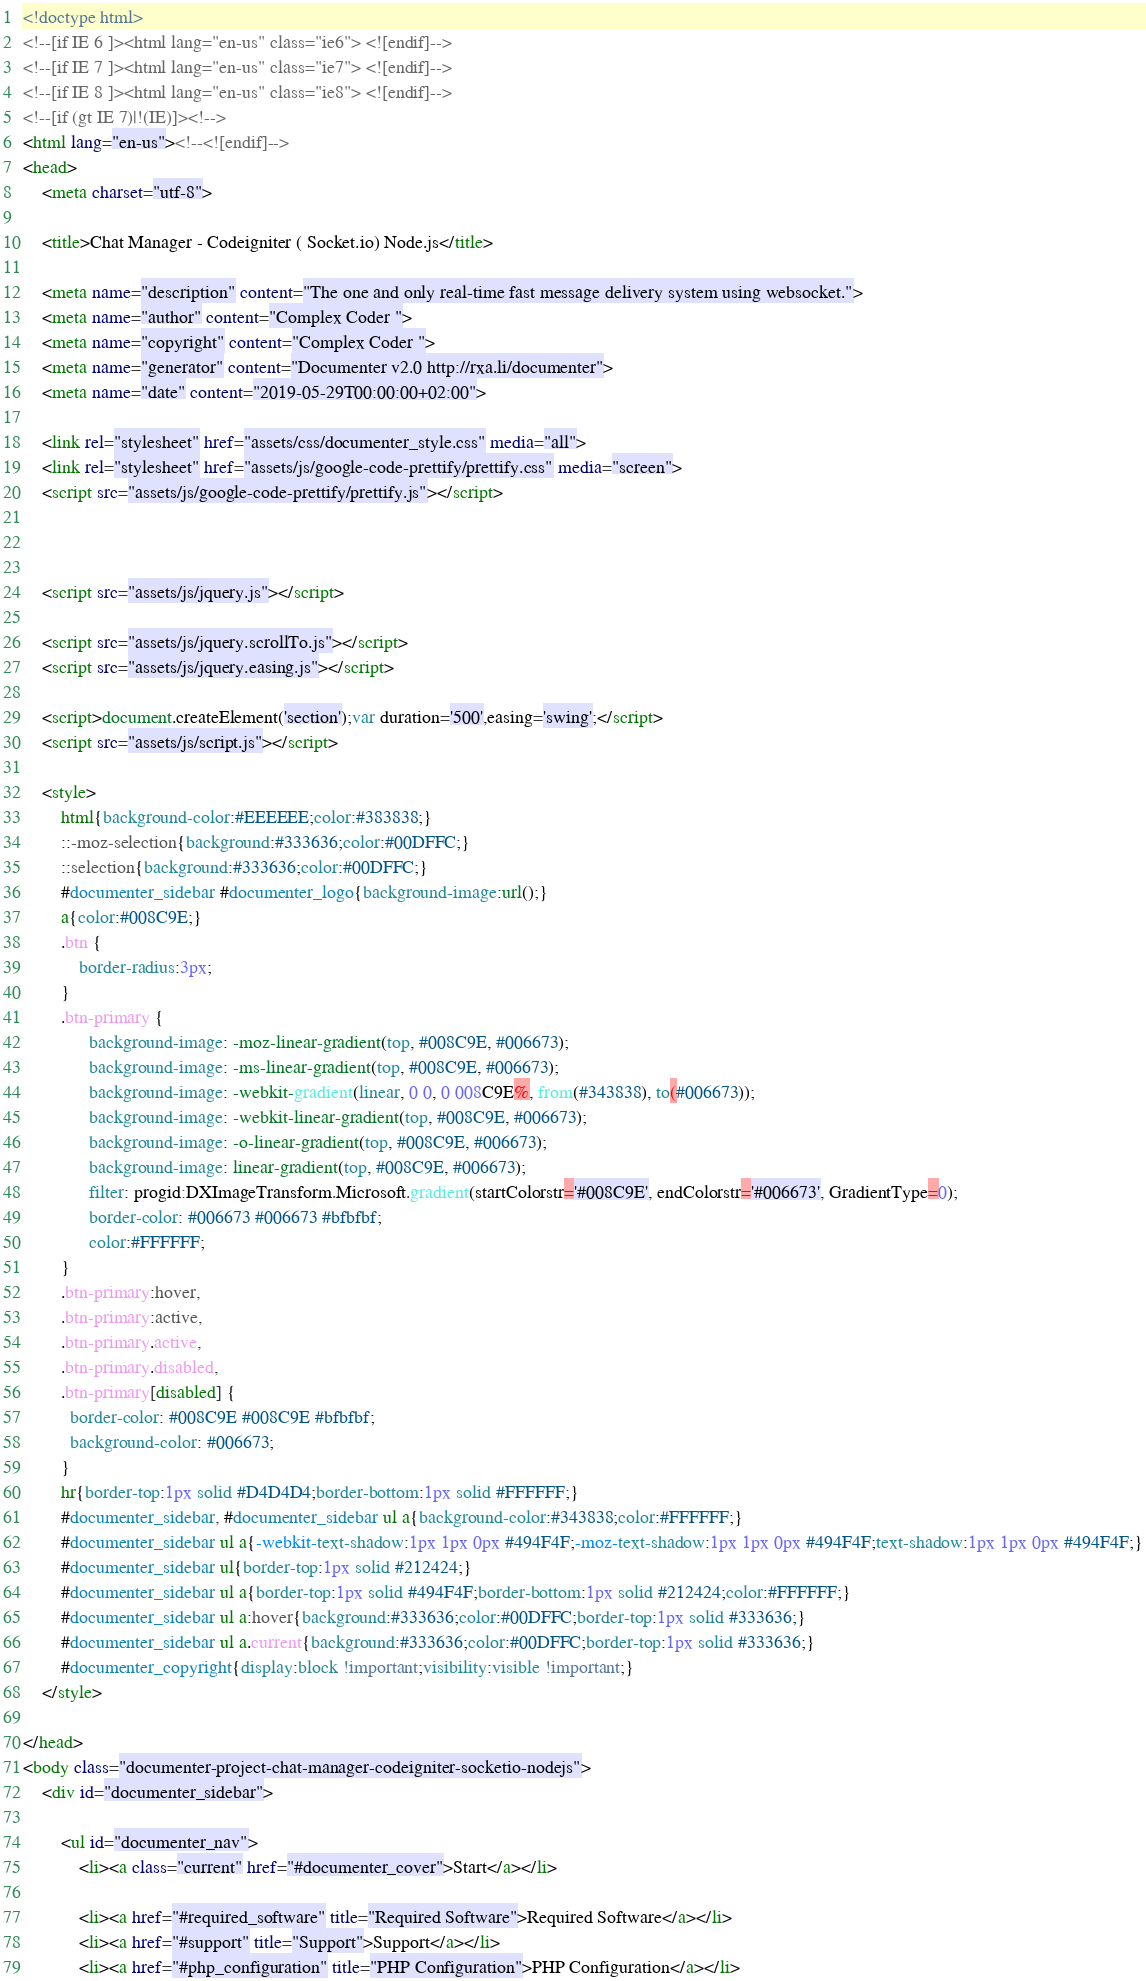Convert code to text. <code><loc_0><loc_0><loc_500><loc_500><_HTML_><!doctype html>  
<!--[if IE 6 ]><html lang="en-us" class="ie6"> <![endif]-->
<!--[if IE 7 ]><html lang="en-us" class="ie7"> <![endif]-->
<!--[if IE 8 ]><html lang="en-us" class="ie8"> <![endif]-->
<!--[if (gt IE 7)|!(IE)]><!-->
<html lang="en-us"><!--<![endif]-->
<head>
	<meta charset="utf-8">
	
	<title>Chat Manager - Codeigniter ( Socket.io) Node.js</title>
	
	<meta name="description" content="The one and only real-time fast message delivery system using websocket.">
	<meta name="author" content="Complex Coder ">
	<meta name="copyright" content="Complex Coder ">
	<meta name="generator" content="Documenter v2.0 http://rxa.li/documenter">
	<meta name="date" content="2019-05-29T00:00:00+02:00">
	
	<link rel="stylesheet" href="assets/css/documenter_style.css" media="all">
	<link rel="stylesheet" href="assets/js/google-code-prettify/prettify.css" media="screen">
	<script src="assets/js/google-code-prettify/prettify.js"></script>

	
	
	<script src="assets/js/jquery.js"></script>
	
	<script src="assets/js/jquery.scrollTo.js"></script>
	<script src="assets/js/jquery.easing.js"></script>
	
	<script>document.createElement('section');var duration='500',easing='swing';</script>
	<script src="assets/js/script.js"></script>
	
	<style>
		html{background-color:#EEEEEE;color:#383838;}
		::-moz-selection{background:#333636;color:#00DFFC;}
		::selection{background:#333636;color:#00DFFC;}
		#documenter_sidebar #documenter_logo{background-image:url();}
		a{color:#008C9E;}
		.btn {
			border-radius:3px;
		}
		.btn-primary {
			  background-image: -moz-linear-gradient(top, #008C9E, #006673);
			  background-image: -ms-linear-gradient(top, #008C9E, #006673);
			  background-image: -webkit-gradient(linear, 0 0, 0 008C9E%, from(#343838), to(#006673));
			  background-image: -webkit-linear-gradient(top, #008C9E, #006673);
			  background-image: -o-linear-gradient(top, #008C9E, #006673);
			  background-image: linear-gradient(top, #008C9E, #006673);
			  filter: progid:DXImageTransform.Microsoft.gradient(startColorstr='#008C9E', endColorstr='#006673', GradientType=0);
			  border-color: #006673 #006673 #bfbfbf;
			  color:#FFFFFF;
		}
		.btn-primary:hover,
		.btn-primary:active,
		.btn-primary.active,
		.btn-primary.disabled,
		.btn-primary[disabled] {
		  border-color: #008C9E #008C9E #bfbfbf;
		  background-color: #006673;
		}
		hr{border-top:1px solid #D4D4D4;border-bottom:1px solid #FFFFFF;}
		#documenter_sidebar, #documenter_sidebar ul a{background-color:#343838;color:#FFFFFF;}
		#documenter_sidebar ul a{-webkit-text-shadow:1px 1px 0px #494F4F;-moz-text-shadow:1px 1px 0px #494F4F;text-shadow:1px 1px 0px #494F4F;}
		#documenter_sidebar ul{border-top:1px solid #212424;}
		#documenter_sidebar ul a{border-top:1px solid #494F4F;border-bottom:1px solid #212424;color:#FFFFFF;}
		#documenter_sidebar ul a:hover{background:#333636;color:#00DFFC;border-top:1px solid #333636;}
		#documenter_sidebar ul a.current{background:#333636;color:#00DFFC;border-top:1px solid #333636;}
		#documenter_copyright{display:block !important;visibility:visible !important;}
	</style>
	
</head>
<body class="documenter-project-chat-manager-codeigniter-socketio-nodejs">
	<div id="documenter_sidebar">
	
		<ul id="documenter_nav">
			<li><a class="current" href="#documenter_cover">Start</a></li>
				
			<li><a href="#required_software" title="Required Software">Required Software</a></li>
			<li><a href="#support" title="Support">Support</a></li>
			<li><a href="#php_configuration" title="PHP Configuration">PHP Configuration</a></li></code> 